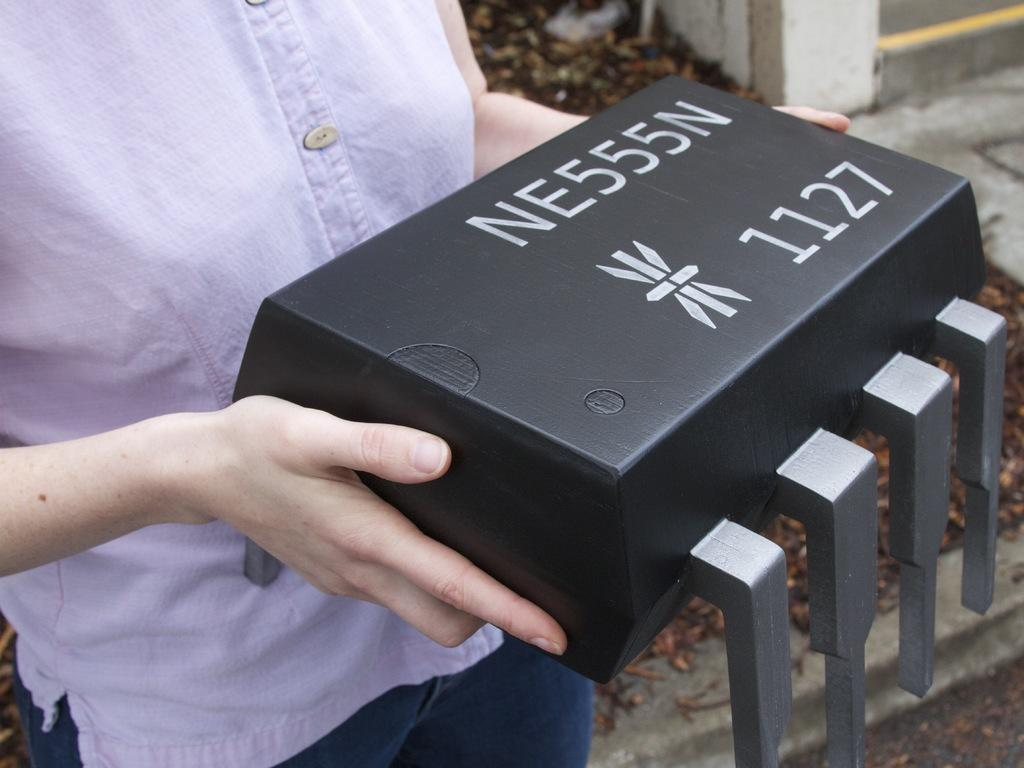What is the person in the image doing? The person is standing in the image and holding a box. What is the box in the image a model of? The box is in the model of a microcontroller. What can be seen in the background of the image? There are leaves in the background of the image. Where is the playground located in the image? There is no playground present in the image. What type of dime is being used to power the microcontroller in the image? The image does not show any dime being used to power the microcontroller; it only shows a person holding a box in the model of a microcontroller. 